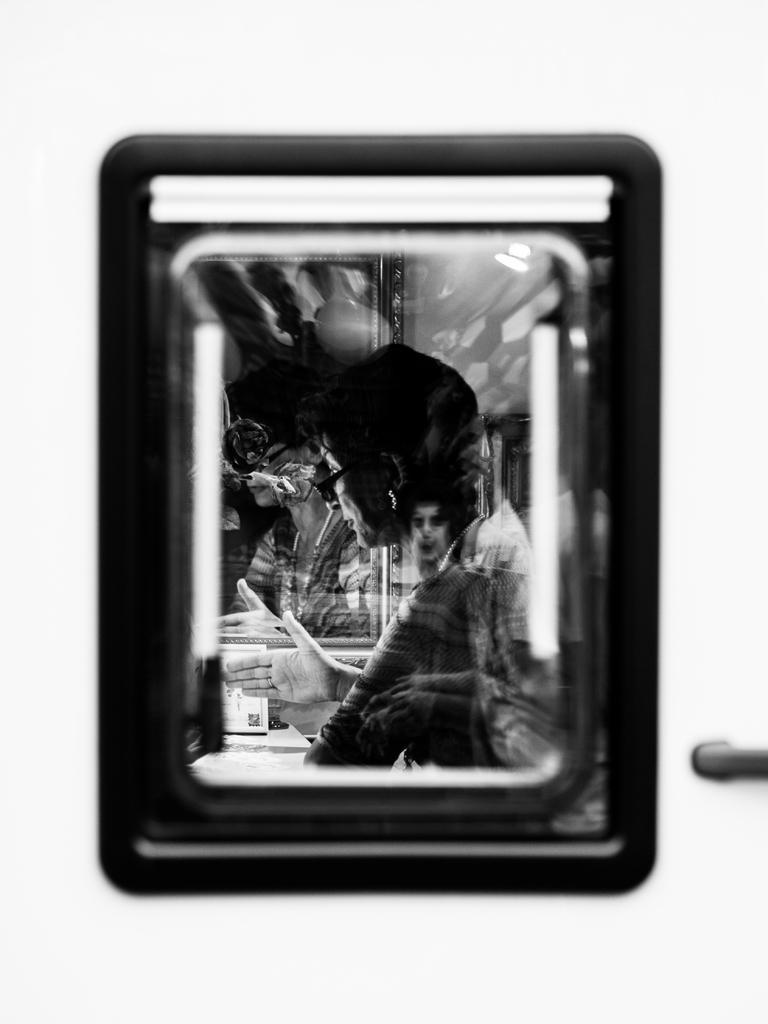Could you give a brief overview of what you see in this image? This is a black and white image. In this we can see a mirror. On the mirror there are persons. And it is looking blurred. 